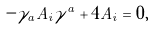Convert formula to latex. <formula><loc_0><loc_0><loc_500><loc_500>- \gamma _ { a } A _ { i } \gamma ^ { a } + 4 A _ { i } = 0 ,</formula> 